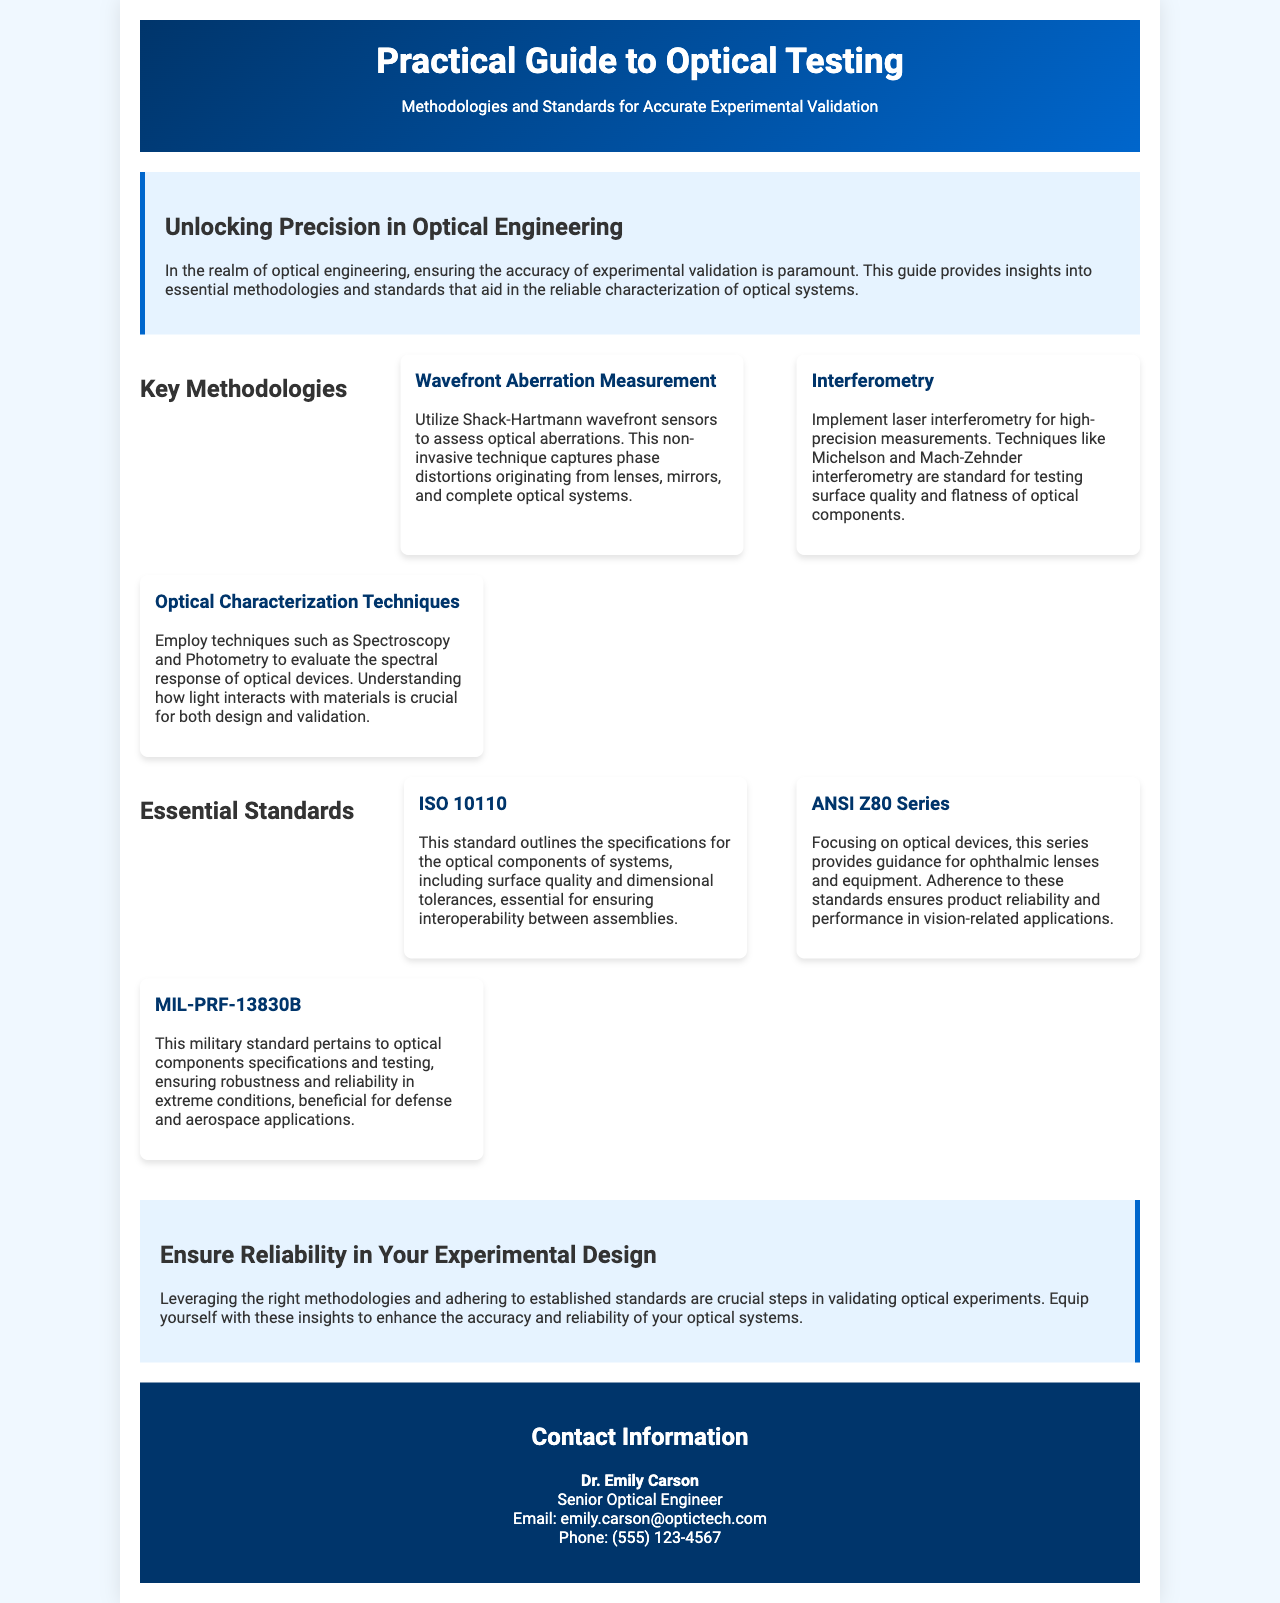what is the title of the document? The title is presented prominently at the top of the brochure.
Answer: Practical Guide to Optical Testing who is the author of the contact section? The contact section provides the name of the person in charge.
Answer: Dr. Emily Carson what methodology is used for wavefront aberration measurement? The document specifies a particular technique used in this methodology.
Answer: Shack-Hartmann wavefront sensors which standard outlines specifications for optical components? The document lists several standards and identifies one specifically for optical components.
Answer: ISO 10110 how many key methodologies are discussed in the document? The section on methodologies lists three distinct methods.
Answer: Three what series provides guidance for ophthalmic lenses? This standard is explicitly mentioned in the essential standards section.
Answer: ANSI Z80 Series what is the main goal of the practical guide? The introduction states the primary purpose of the guide.
Answer: Accurate experimental validation what is the main color of the header section? The header contains specific colors mentioned in the design of the brochure.
Answer: Blue what is the phone number listed for the contact? The contact section includes a specific number.
Answer: (555) 123-4567 